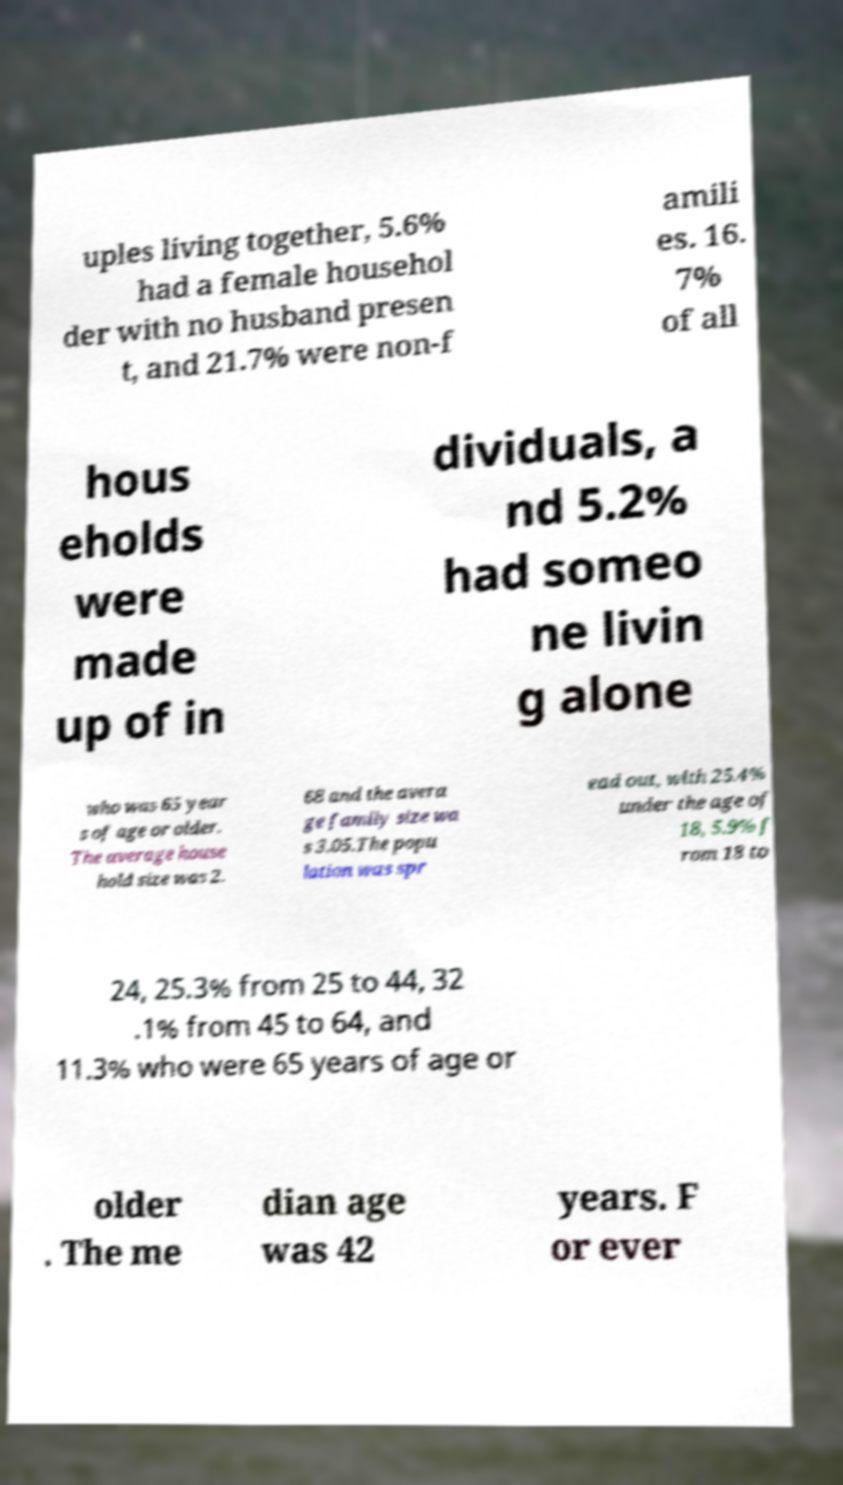Please identify and transcribe the text found in this image. uples living together, 5.6% had a female househol der with no husband presen t, and 21.7% were non-f amili es. 16. 7% of all hous eholds were made up of in dividuals, a nd 5.2% had someo ne livin g alone who was 65 year s of age or older. The average house hold size was 2. 68 and the avera ge family size wa s 3.05.The popu lation was spr ead out, with 25.4% under the age of 18, 5.9% f rom 18 to 24, 25.3% from 25 to 44, 32 .1% from 45 to 64, and 11.3% who were 65 years of age or older . The me dian age was 42 years. F or ever 